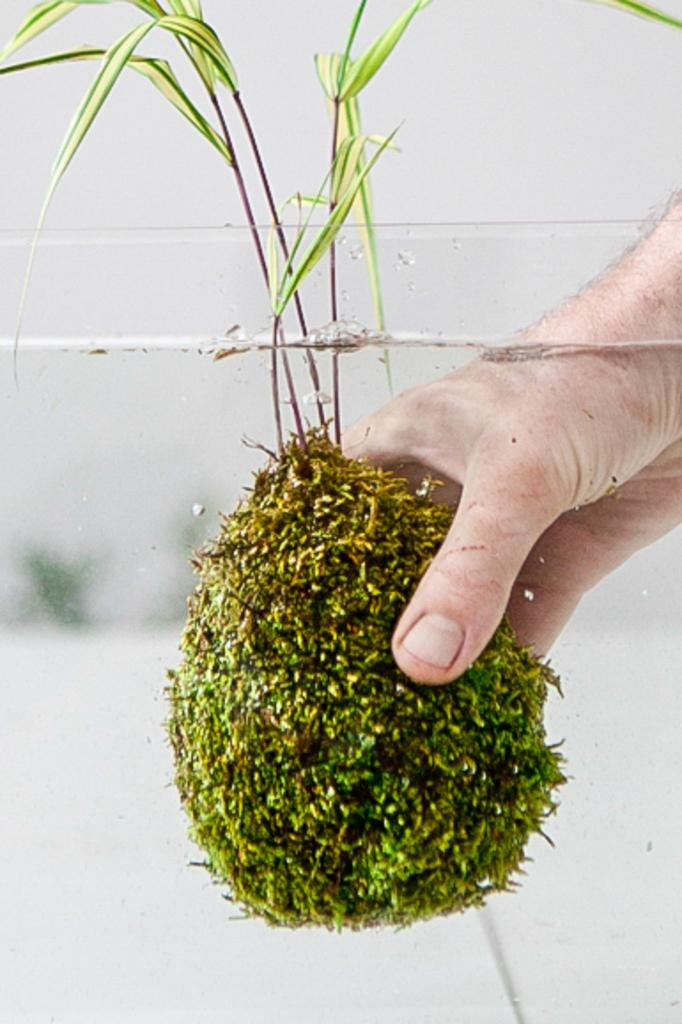What is the person holding in the image? A person's hand is holding a plant in the image. How is the plant being supported in the image? The plant is in water, which is contained in a glass tub. What can be seen in the background of the image? There is a white wall in the background of the image. How many bikes are parked next to the white wall in the image? There are no bikes present in the image; it only features a person's hand holding a plant in water. 